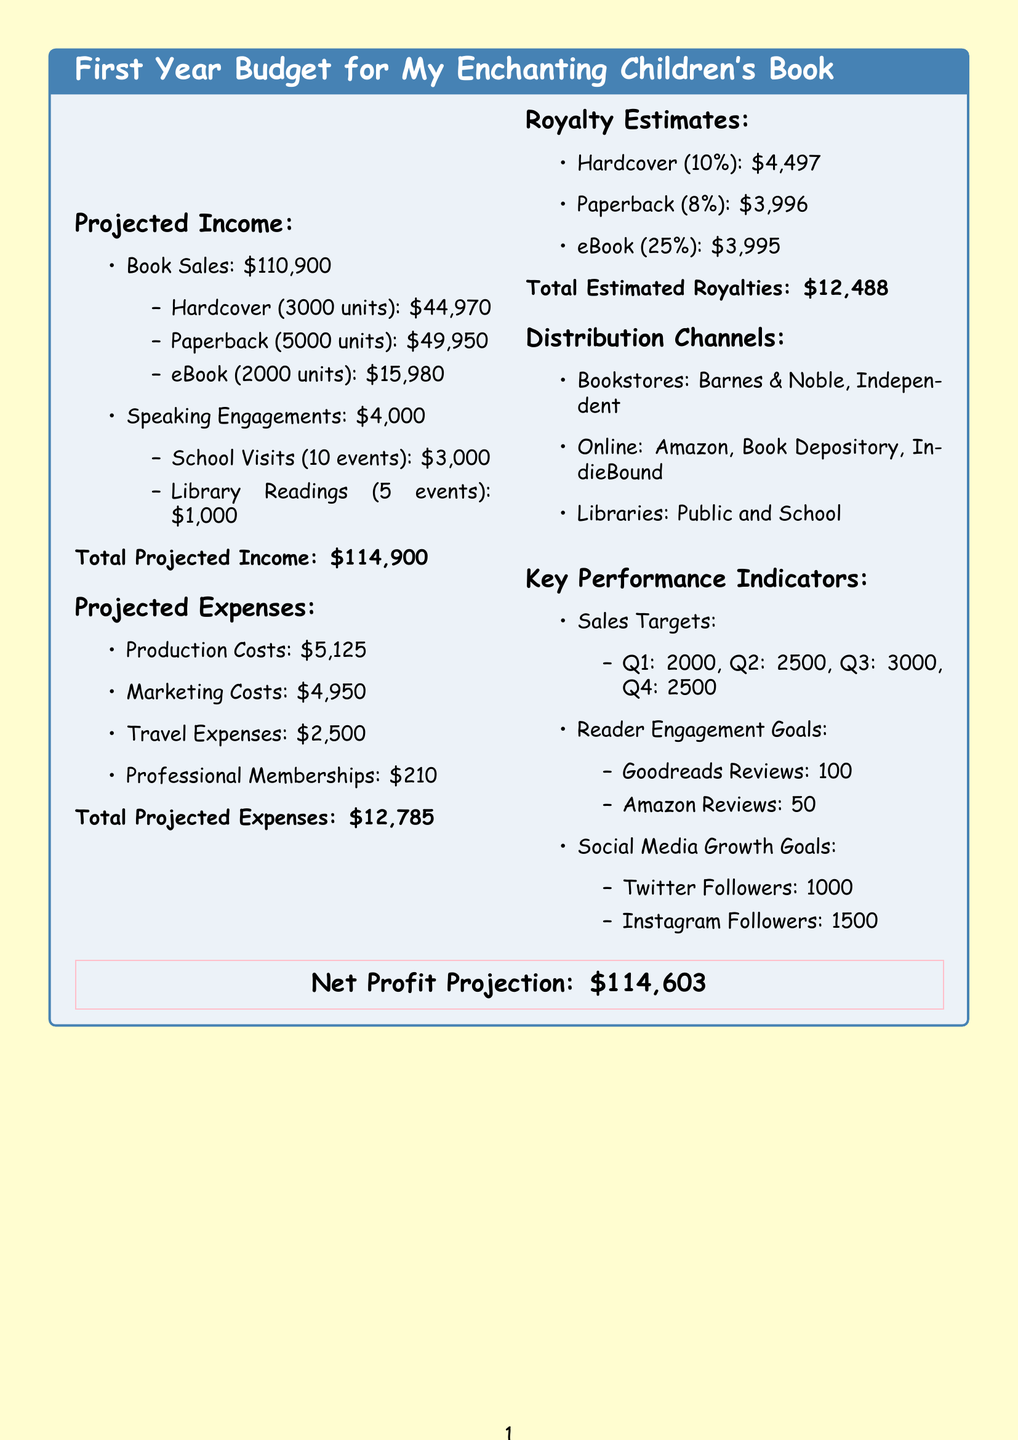what is the total projected income? The total projected income is stated in the document summary at the end of the projected income section.
Answer: $114,900 how many hardcover units are projected to be sold? The number of hardcover units is listed under the book sales section of the projected income.
Answer: 3000 what are the total marketing costs? Total marketing costs are summarized in the projected expenses section.
Answer: $4,950 what is the royalty rate for paperbacks? The royalty rate for paperbacks is mentioned in the royalty estimates section.
Answer: 8% how much is estimated from school visits? The total from school visits is specifically outlined in the speaking engagements section.
Answer: $3,000 what is the net profit projection? The net profit projection is presented in the visual section at the bottom of the document.
Answer: $114,603 how many Goodreads reviews are targeted? The targeted Goodreads reviews are indicated in the key performance indicators section.
Answer: 100 how many events are planned for library readings? The number of events for library readings is detailed in the speaking engagements part of projected income.
Answer: 5 what type of bookstores are included in distribution channels? The types of bookstores in distribution channels are explicitly listed in the respective section.
Answer: Barnes & Noble, Independent 